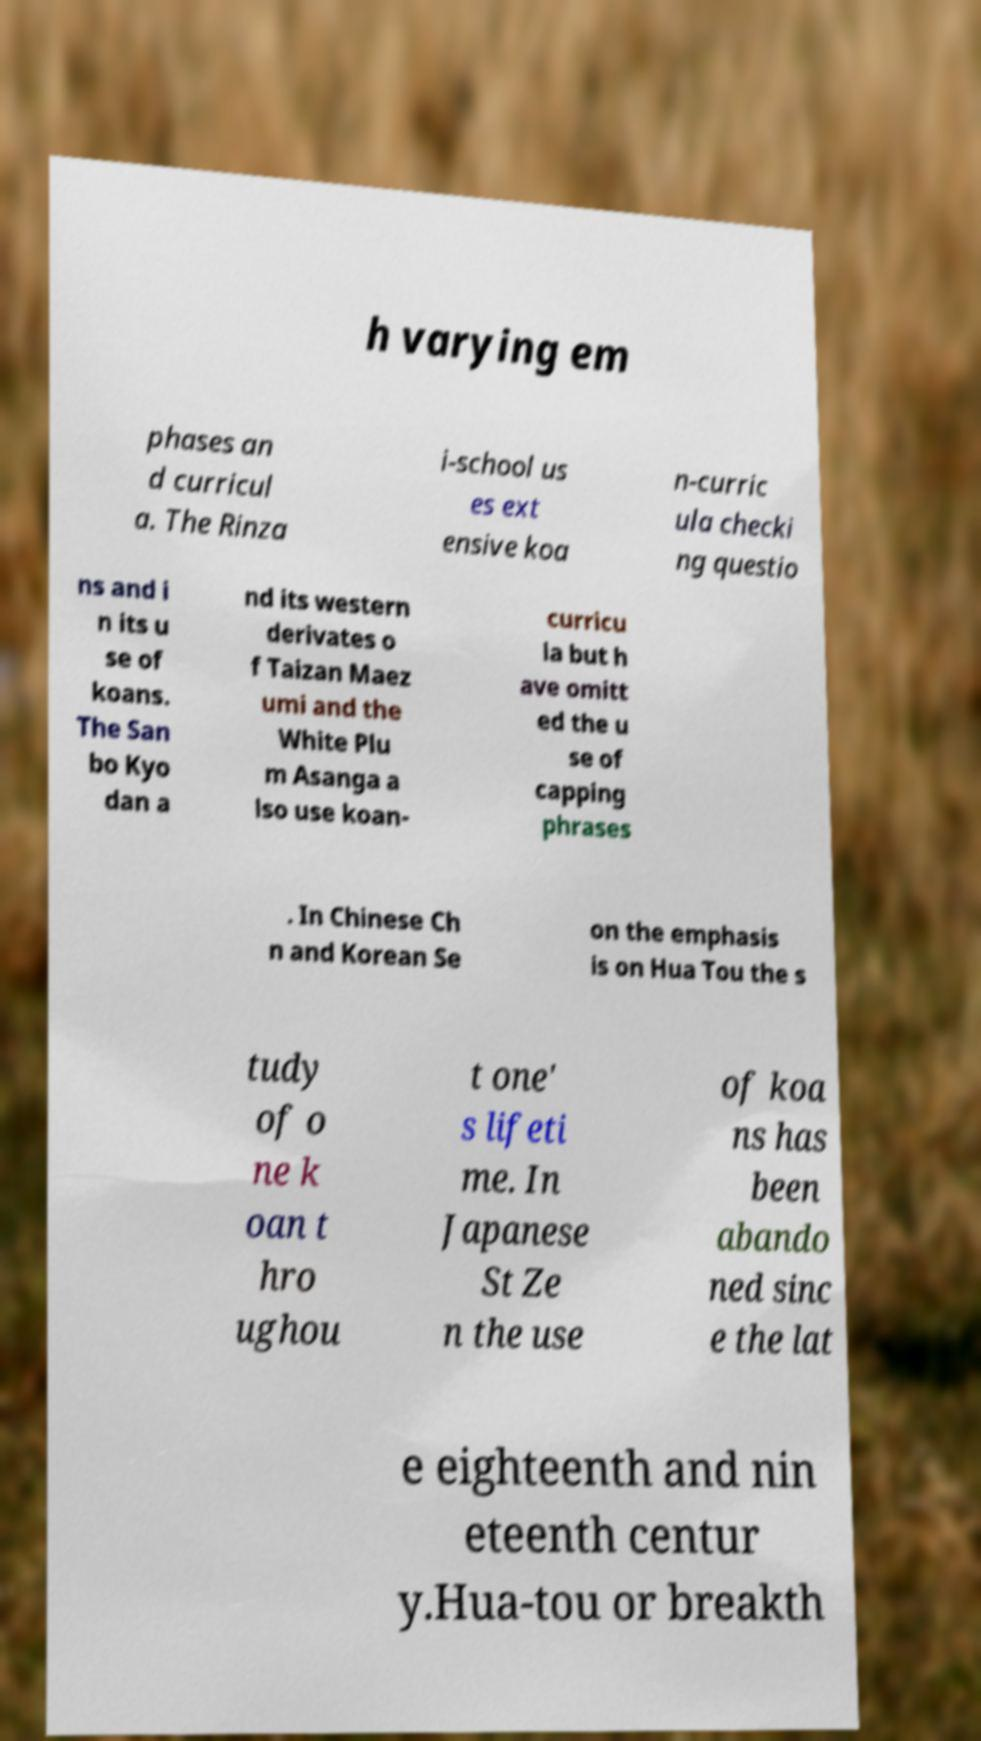There's text embedded in this image that I need extracted. Can you transcribe it verbatim? h varying em phases an d curricul a. The Rinza i-school us es ext ensive koa n-curric ula checki ng questio ns and i n its u se of koans. The San bo Kyo dan a nd its western derivates o f Taizan Maez umi and the White Plu m Asanga a lso use koan- curricu la but h ave omitt ed the u se of capping phrases . In Chinese Ch n and Korean Se on the emphasis is on Hua Tou the s tudy of o ne k oan t hro ughou t one' s lifeti me. In Japanese St Ze n the use of koa ns has been abando ned sinc e the lat e eighteenth and nin eteenth centur y.Hua-tou or breakth 